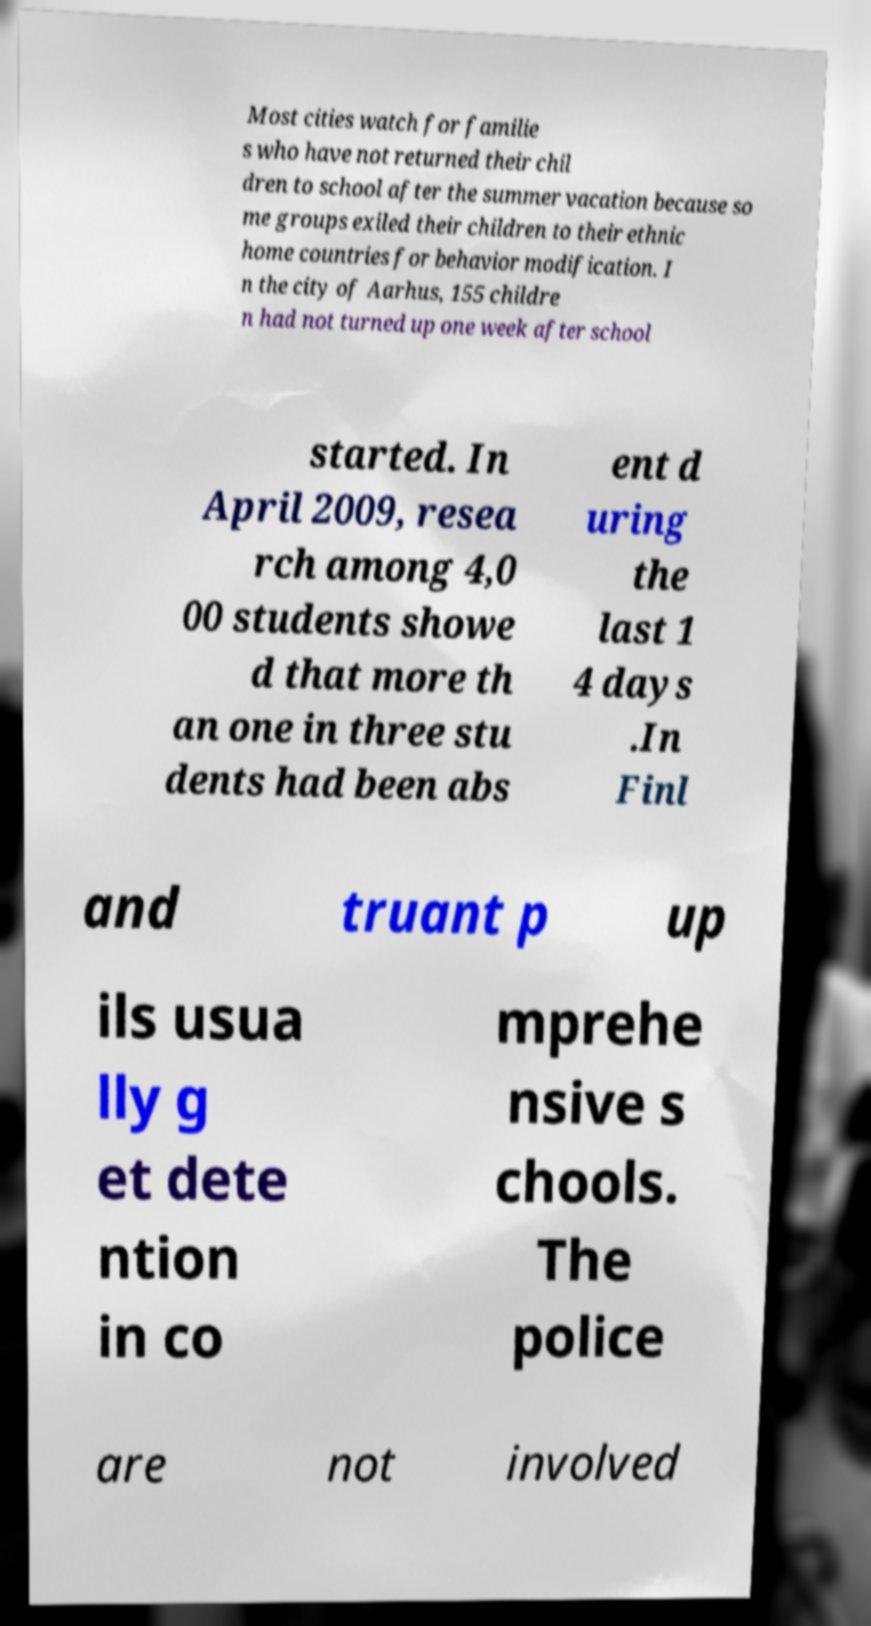What messages or text are displayed in this image? I need them in a readable, typed format. Most cities watch for familie s who have not returned their chil dren to school after the summer vacation because so me groups exiled their children to their ethnic home countries for behavior modification. I n the city of Aarhus, 155 childre n had not turned up one week after school started. In April 2009, resea rch among 4,0 00 students showe d that more th an one in three stu dents had been abs ent d uring the last 1 4 days .In Finl and truant p up ils usua lly g et dete ntion in co mprehe nsive s chools. The police are not involved 